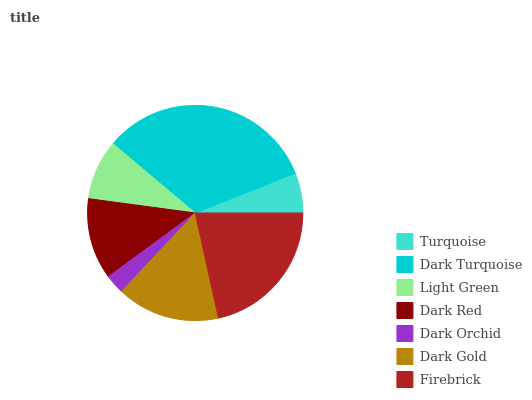Is Dark Orchid the minimum?
Answer yes or no. Yes. Is Dark Turquoise the maximum?
Answer yes or no. Yes. Is Light Green the minimum?
Answer yes or no. No. Is Light Green the maximum?
Answer yes or no. No. Is Dark Turquoise greater than Light Green?
Answer yes or no. Yes. Is Light Green less than Dark Turquoise?
Answer yes or no. Yes. Is Light Green greater than Dark Turquoise?
Answer yes or no. No. Is Dark Turquoise less than Light Green?
Answer yes or no. No. Is Dark Red the high median?
Answer yes or no. Yes. Is Dark Red the low median?
Answer yes or no. Yes. Is Dark Gold the high median?
Answer yes or no. No. Is Firebrick the low median?
Answer yes or no. No. 